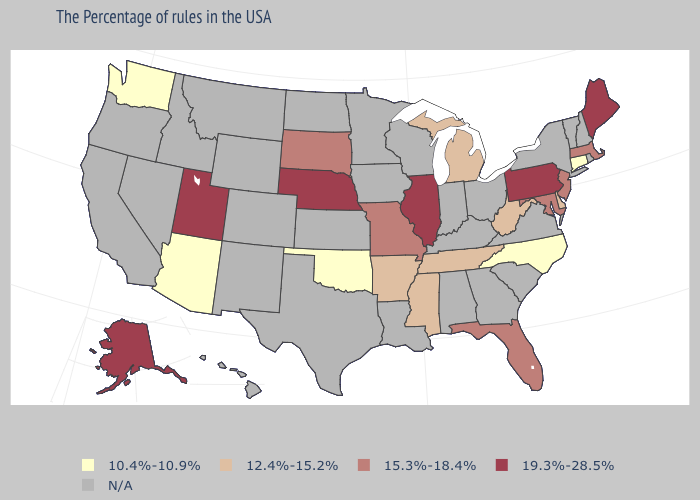Name the states that have a value in the range 10.4%-10.9%?
Concise answer only. Connecticut, North Carolina, Oklahoma, Arizona, Washington. What is the value of Iowa?
Concise answer only. N/A. What is the value of Nebraska?
Give a very brief answer. 19.3%-28.5%. Which states hav the highest value in the Northeast?
Be succinct. Maine, Pennsylvania. What is the value of Nevada?
Quick response, please. N/A. Name the states that have a value in the range 10.4%-10.9%?
Give a very brief answer. Connecticut, North Carolina, Oklahoma, Arizona, Washington. Name the states that have a value in the range 12.4%-15.2%?
Concise answer only. Delaware, West Virginia, Michigan, Tennessee, Mississippi, Arkansas. Name the states that have a value in the range 12.4%-15.2%?
Give a very brief answer. Delaware, West Virginia, Michigan, Tennessee, Mississippi, Arkansas. What is the value of Nevada?
Short answer required. N/A. Does Illinois have the highest value in the USA?
Give a very brief answer. Yes. Which states have the highest value in the USA?
Write a very short answer. Maine, Pennsylvania, Illinois, Nebraska, Utah, Alaska. Does Pennsylvania have the highest value in the Northeast?
Be succinct. Yes. 